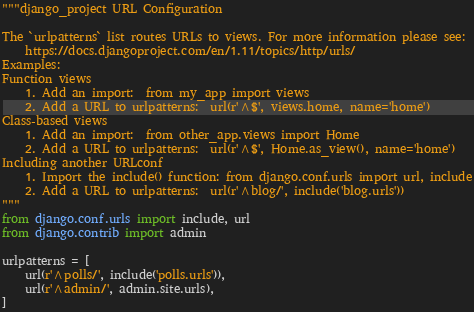Convert code to text. <code><loc_0><loc_0><loc_500><loc_500><_Python_>"""django_project URL Configuration

The `urlpatterns` list routes URLs to views. For more information please see:
    https://docs.djangoproject.com/en/1.11/topics/http/urls/
Examples:
Function views
    1. Add an import:  from my_app import views
    2. Add a URL to urlpatterns:  url(r'^$', views.home, name='home')
Class-based views
    1. Add an import:  from other_app.views import Home
    2. Add a URL to urlpatterns:  url(r'^$', Home.as_view(), name='home')
Including another URLconf
    1. Import the include() function: from django.conf.urls import url, include
    2. Add a URL to urlpatterns:  url(r'^blog/', include('blog.urls'))
"""
from django.conf.urls import include, url
from django.contrib import admin

urlpatterns = [
	url(r'^polls/', include('polls.urls')),
    url(r'^admin/', admin.site.urls),
]
</code> 